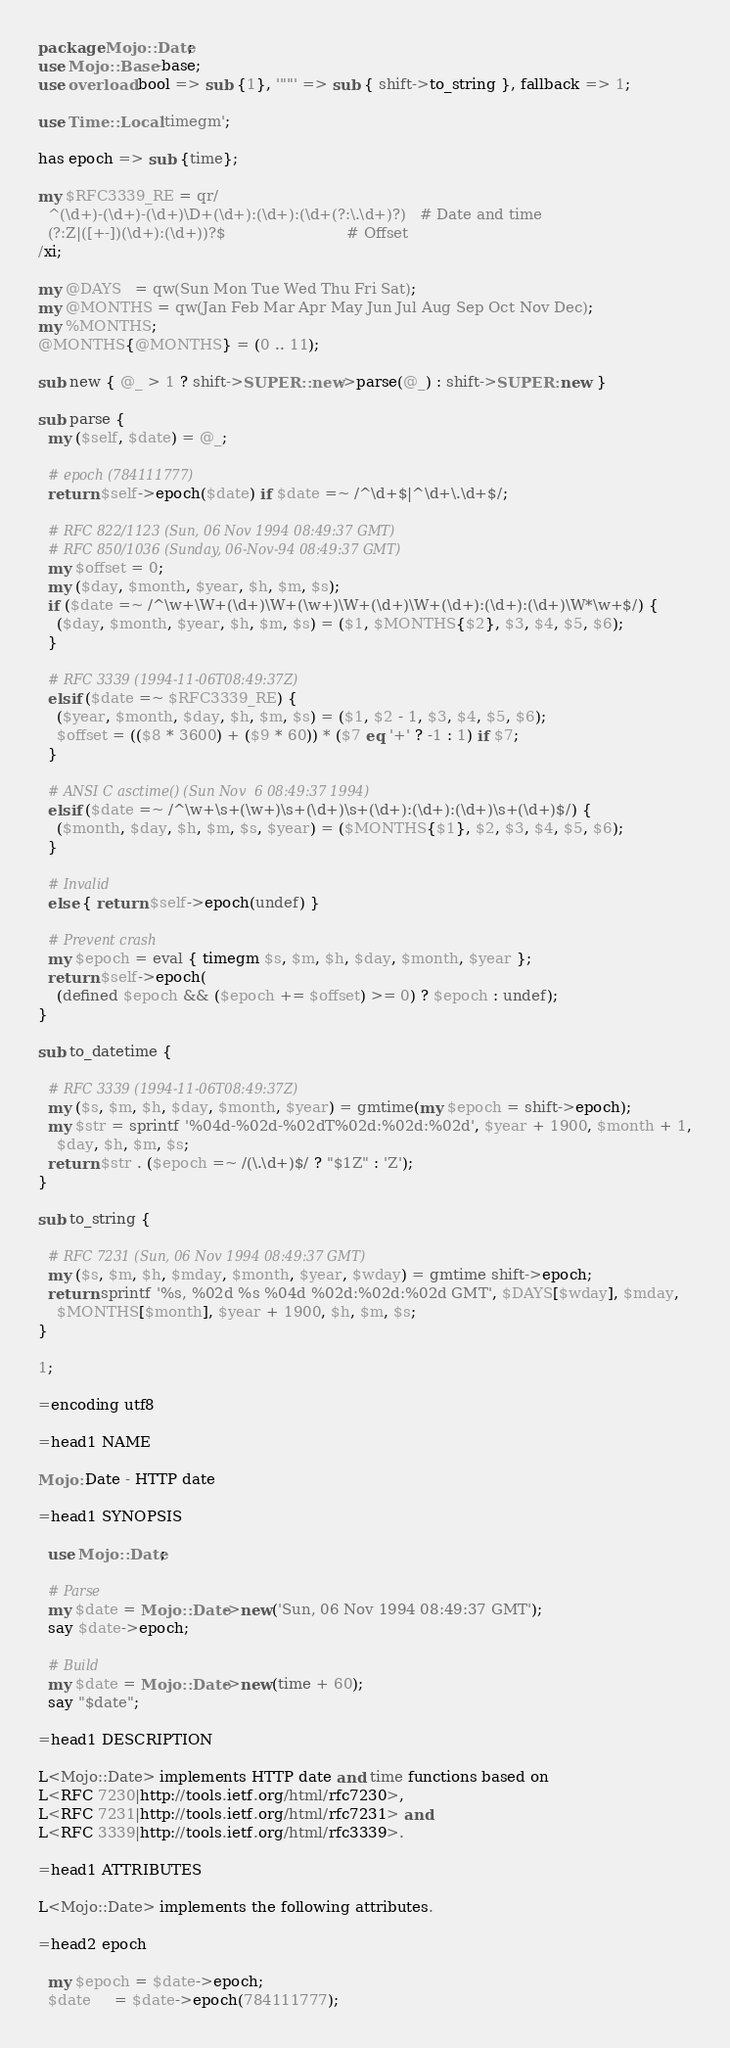<code> <loc_0><loc_0><loc_500><loc_500><_Perl_>package Mojo::Date;
use Mojo::Base -base;
use overload bool => sub {1}, '""' => sub { shift->to_string }, fallback => 1;

use Time::Local 'timegm';

has epoch => sub {time};

my $RFC3339_RE = qr/
  ^(\d+)-(\d+)-(\d+)\D+(\d+):(\d+):(\d+(?:\.\d+)?)   # Date and time
  (?:Z|([+-])(\d+):(\d+))?$                          # Offset
/xi;

my @DAYS   = qw(Sun Mon Tue Wed Thu Fri Sat);
my @MONTHS = qw(Jan Feb Mar Apr May Jun Jul Aug Sep Oct Nov Dec);
my %MONTHS;
@MONTHS{@MONTHS} = (0 .. 11);

sub new { @_ > 1 ? shift->SUPER::new->parse(@_) : shift->SUPER::new }

sub parse {
  my ($self, $date) = @_;

  # epoch (784111777)
  return $self->epoch($date) if $date =~ /^\d+$|^\d+\.\d+$/;

  # RFC 822/1123 (Sun, 06 Nov 1994 08:49:37 GMT)
  # RFC 850/1036 (Sunday, 06-Nov-94 08:49:37 GMT)
  my $offset = 0;
  my ($day, $month, $year, $h, $m, $s);
  if ($date =~ /^\w+\W+(\d+)\W+(\w+)\W+(\d+)\W+(\d+):(\d+):(\d+)\W*\w+$/) {
    ($day, $month, $year, $h, $m, $s) = ($1, $MONTHS{$2}, $3, $4, $5, $6);
  }

  # RFC 3339 (1994-11-06T08:49:37Z)
  elsif ($date =~ $RFC3339_RE) {
    ($year, $month, $day, $h, $m, $s) = ($1, $2 - 1, $3, $4, $5, $6);
    $offset = (($8 * 3600) + ($9 * 60)) * ($7 eq '+' ? -1 : 1) if $7;
  }

  # ANSI C asctime() (Sun Nov  6 08:49:37 1994)
  elsif ($date =~ /^\w+\s+(\w+)\s+(\d+)\s+(\d+):(\d+):(\d+)\s+(\d+)$/) {
    ($month, $day, $h, $m, $s, $year) = ($MONTHS{$1}, $2, $3, $4, $5, $6);
  }

  # Invalid
  else { return $self->epoch(undef) }

  # Prevent crash
  my $epoch = eval { timegm $s, $m, $h, $day, $month, $year };
  return $self->epoch(
    (defined $epoch && ($epoch += $offset) >= 0) ? $epoch : undef);
}

sub to_datetime {

  # RFC 3339 (1994-11-06T08:49:37Z)
  my ($s, $m, $h, $day, $month, $year) = gmtime(my $epoch = shift->epoch);
  my $str = sprintf '%04d-%02d-%02dT%02d:%02d:%02d', $year + 1900, $month + 1,
    $day, $h, $m, $s;
  return $str . ($epoch =~ /(\.\d+)$/ ? "$1Z" : 'Z');
}

sub to_string {

  # RFC 7231 (Sun, 06 Nov 1994 08:49:37 GMT)
  my ($s, $m, $h, $mday, $month, $year, $wday) = gmtime shift->epoch;
  return sprintf '%s, %02d %s %04d %02d:%02d:%02d GMT', $DAYS[$wday], $mday,
    $MONTHS[$month], $year + 1900, $h, $m, $s;
}

1;

=encoding utf8

=head1 NAME

Mojo::Date - HTTP date

=head1 SYNOPSIS

  use Mojo::Date;

  # Parse
  my $date = Mojo::Date->new('Sun, 06 Nov 1994 08:49:37 GMT');
  say $date->epoch;

  # Build
  my $date = Mojo::Date->new(time + 60);
  say "$date";

=head1 DESCRIPTION

L<Mojo::Date> implements HTTP date and time functions based on
L<RFC 7230|http://tools.ietf.org/html/rfc7230>,
L<RFC 7231|http://tools.ietf.org/html/rfc7231> and
L<RFC 3339|http://tools.ietf.org/html/rfc3339>.

=head1 ATTRIBUTES

L<Mojo::Date> implements the following attributes.

=head2 epoch

  my $epoch = $date->epoch;
  $date     = $date->epoch(784111777);
</code> 